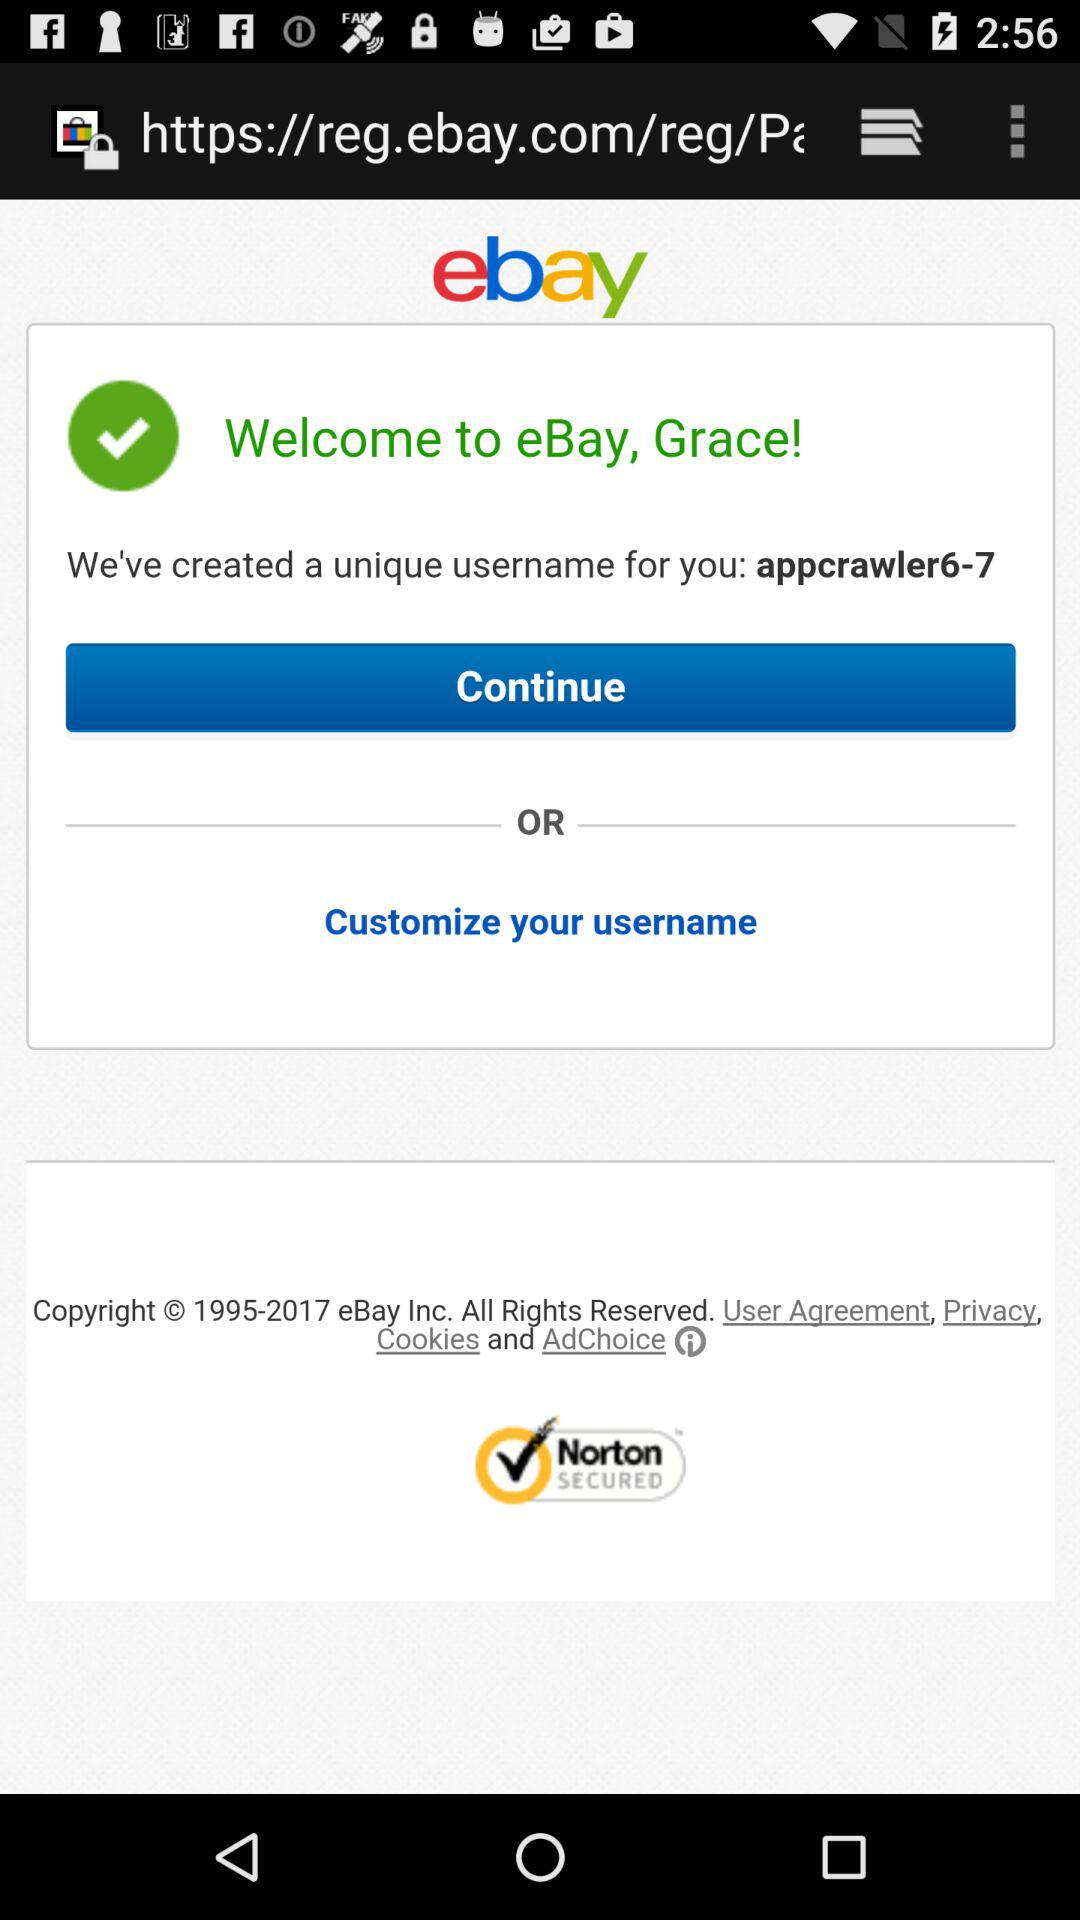What company has all the copyrights? The company "eBay Inc." has all the copyrights. 